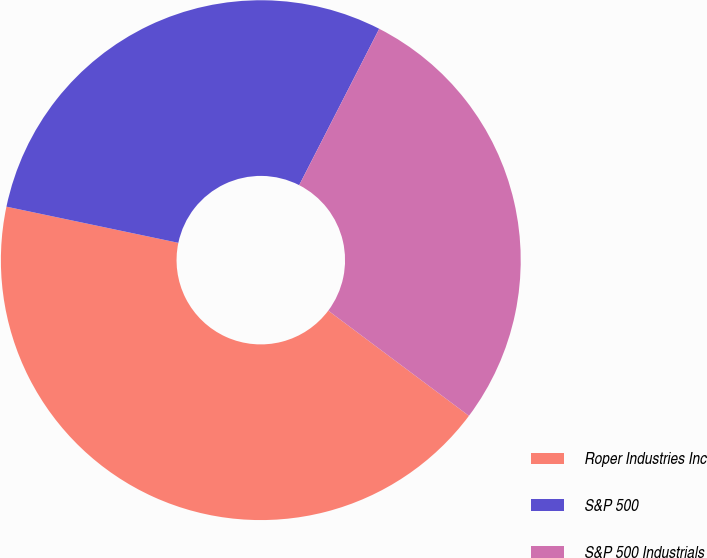Convert chart to OTSL. <chart><loc_0><loc_0><loc_500><loc_500><pie_chart><fcel>Roper Industries Inc<fcel>S&P 500<fcel>S&P 500 Industrials<nl><fcel>43.08%<fcel>29.23%<fcel>27.69%<nl></chart> 